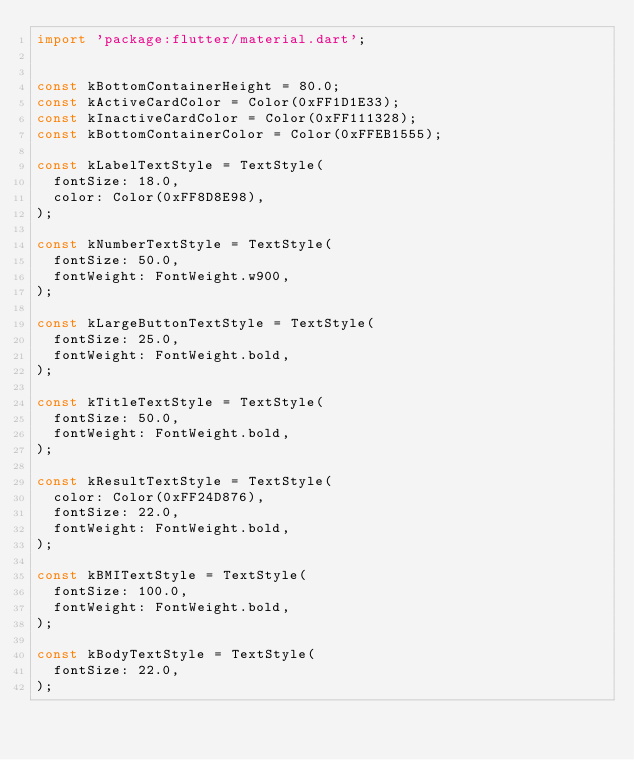<code> <loc_0><loc_0><loc_500><loc_500><_Dart_>import 'package:flutter/material.dart';


const kBottomContainerHeight = 80.0;
const kActiveCardColor = Color(0xFF1D1E33);
const kInactiveCardColor = Color(0xFF111328);
const kBottomContainerColor = Color(0xFFEB1555);

const kLabelTextStyle = TextStyle(
  fontSize: 18.0,
  color: Color(0xFF8D8E98),
);

const kNumberTextStyle = TextStyle(
  fontSize: 50.0,
  fontWeight: FontWeight.w900,
);

const kLargeButtonTextStyle = TextStyle(
  fontSize: 25.0,
  fontWeight: FontWeight.bold,
);

const kTitleTextStyle = TextStyle(
  fontSize: 50.0,
  fontWeight: FontWeight.bold,
);

const kResultTextStyle = TextStyle(
  color: Color(0xFF24D876),
  fontSize: 22.0,
  fontWeight: FontWeight.bold,
);

const kBMITextStyle = TextStyle(
  fontSize: 100.0,
  fontWeight: FontWeight.bold,
);

const kBodyTextStyle = TextStyle(
  fontSize: 22.0,
);</code> 